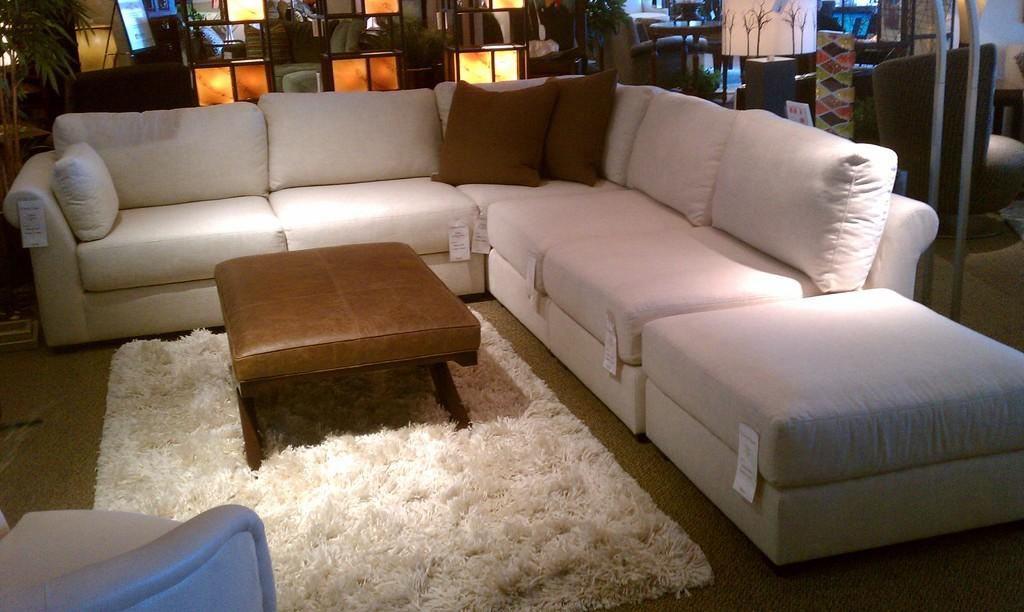What type of furniture is present in the image? There is a sofa and a table in the image. What is covering the floor in the image? There is a carpet in the image. What color is the carpet? The carpet is white. What type of decorative element can be seen in the image? There is a plant behind the sofa. What type of linen is used to cover the sofa in the image? There is no information about the type of linen used to cover the sofa in the image. 